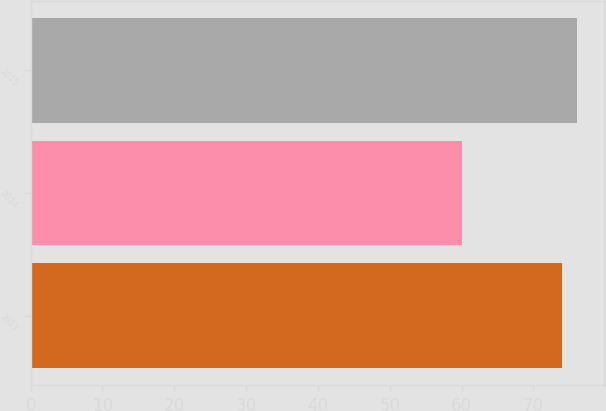<chart> <loc_0><loc_0><loc_500><loc_500><bar_chart><fcel>2013<fcel>2014<fcel>2015<nl><fcel>74<fcel>60<fcel>76<nl></chart> 